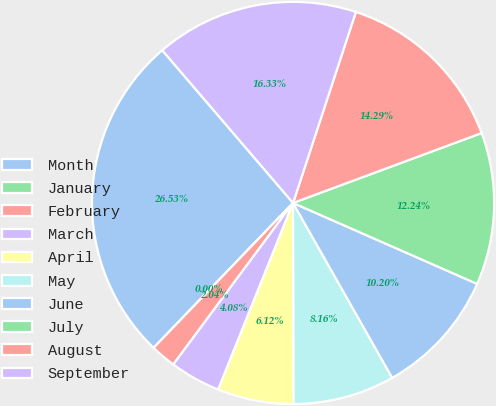Convert chart. <chart><loc_0><loc_0><loc_500><loc_500><pie_chart><fcel>Month<fcel>January<fcel>February<fcel>March<fcel>April<fcel>May<fcel>June<fcel>July<fcel>August<fcel>September<nl><fcel>26.53%<fcel>0.0%<fcel>2.04%<fcel>4.08%<fcel>6.12%<fcel>8.16%<fcel>10.2%<fcel>12.24%<fcel>14.29%<fcel>16.33%<nl></chart> 